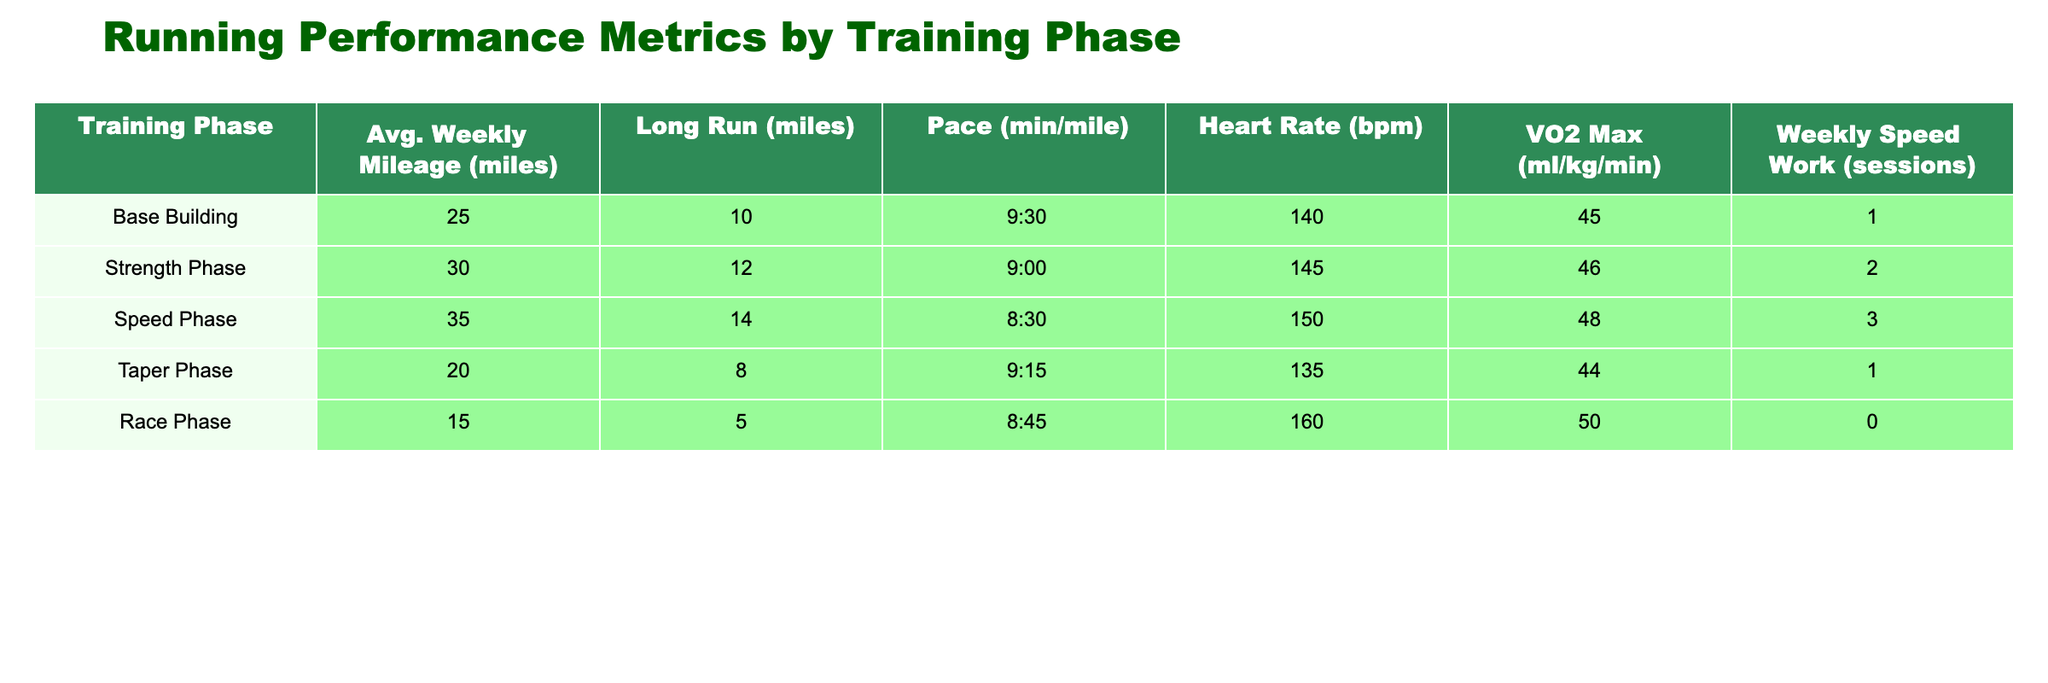What is the average weekly mileage during the Strength Phase? The average weekly mileage for the Strength Phase is provided directly in the table as 30 miles.
Answer: 30 miles How many long run miles are in the Speed Phase? The long run miles for the Speed Phase are indicated in the table and listed as 14 miles.
Answer: 14 miles Is the heart rate during the Taper Phase lower than during the Speed Phase? The heart rate for the Taper Phase is 135 bpm, while for the Speed Phase it is 150 bpm. Since 135 is lower than 150, the answer is yes.
Answer: Yes What is the difference in pace between the Race Phase and the Base Building Phase? The pace during the Race Phase is 8:45 min/mile and for the Base Building Phase is 9:30 min/mile. To find the difference, convert both to minutes: Race Phase is 8.75 minutes and Base Building is 9.50 minutes. The difference is 9.50 - 8.75 = 0.75 minutes.
Answer: 0.75 minutes Which training phase has the highest VO2 Max value? By comparing the VO2 Max values in the table, the Race Phase shows a VO2 Max of 50 ml/kg/min, which is the highest compared to the other phases listed.
Answer: Race Phase How many weekly speed work sessions are there in the Base Building Phase and Taper Phase combined? The Base Building Phase has 1 speed work session and the Taper Phase has 1 speed work session. Adding those together gives 1 + 1 = 2 sessions.
Answer: 2 sessions In which training phase is the longest long run recorded? By examining the long run values in the table, the Speed Phase has the longest long run at 14 miles, compared to the other phases listed.
Answer: Speed Phase What is the average heart rate across all training phases? To find the average heart rate, sum the heart rates: 140 + 145 + 150 + 135 + 160 = 730 bpm. Then divide by the number of phases, which is 5. So, 730 / 5 = 146 bpm.
Answer: 146 bpm 